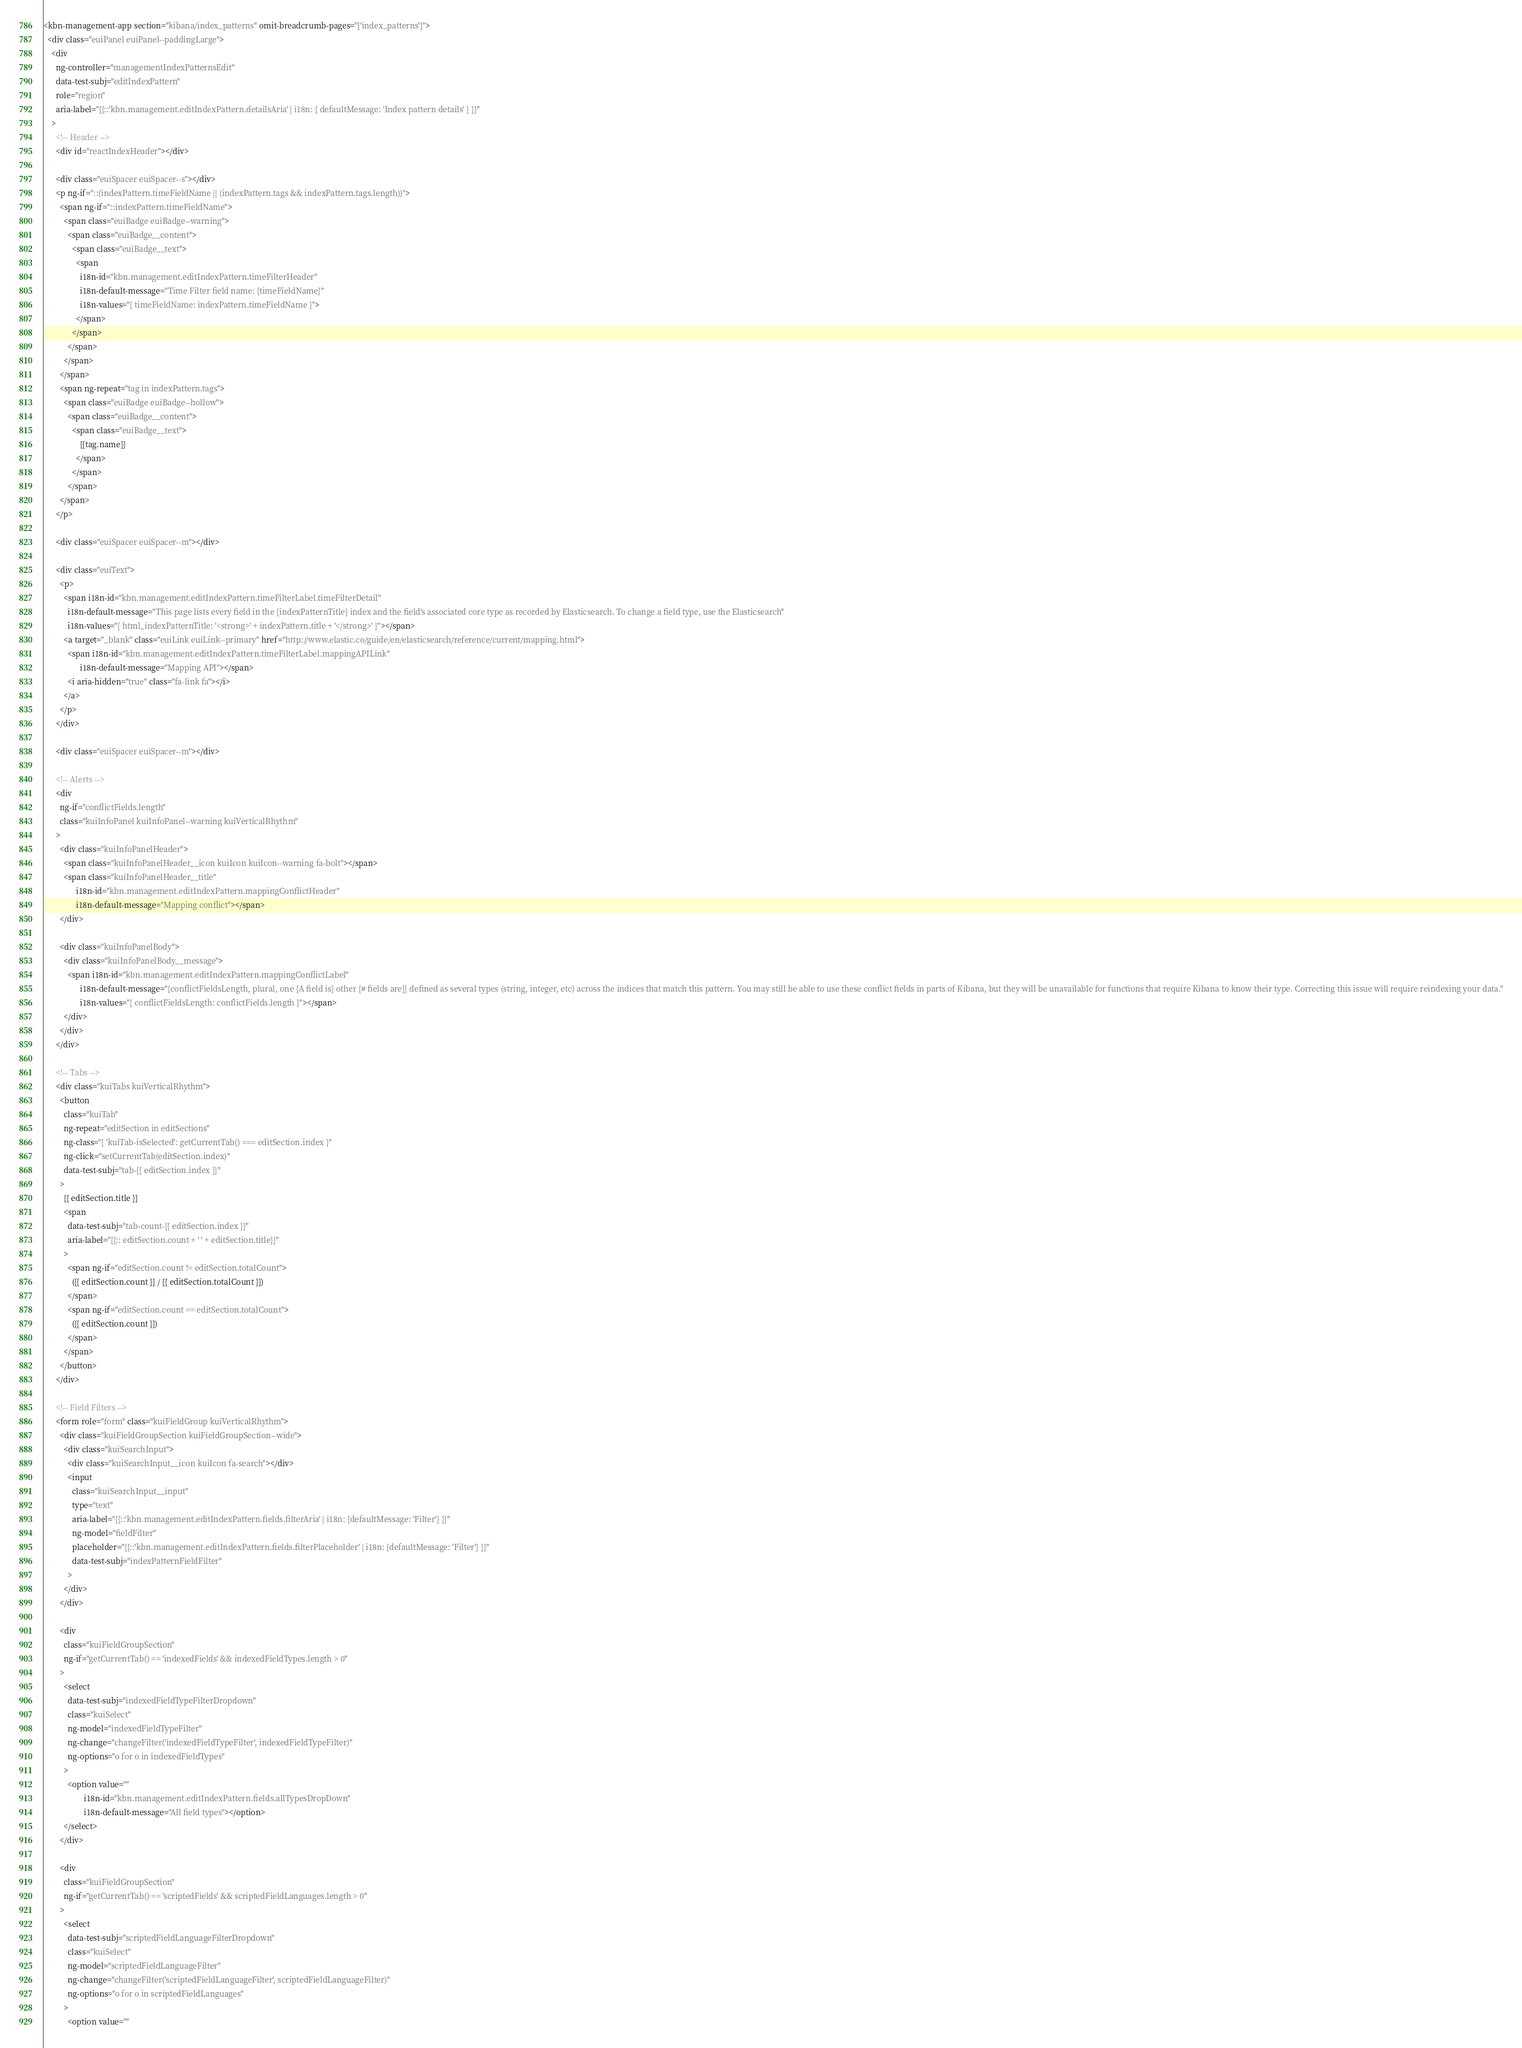Convert code to text. <code><loc_0><loc_0><loc_500><loc_500><_HTML_><kbn-management-app section="kibana/index_patterns" omit-breadcrumb-pages="['index_patterns']">
  <div class="euiPanel euiPanel--paddingLarge">
    <div
      ng-controller="managementIndexPatternsEdit"
      data-test-subj="editIndexPattern"
      role="region"
      aria-label="{{::'kbn.management.editIndexPattern.detailsAria' | i18n: { defaultMessage: 'Index pattern details' } }}"
    >
      <!-- Header -->
      <div id="reactIndexHeader"></div>

      <div class="euiSpacer euiSpacer--s"></div>
      <p ng-if="::(indexPattern.timeFieldName || (indexPattern.tags && indexPattern.tags.length))">
        <span ng-if="::indexPattern.timeFieldName">
          <span class="euiBadge euiBadge--warning">
            <span class="euiBadge__content">
              <span class="euiBadge__text">
                <span
                  i18n-id="kbn.management.editIndexPattern.timeFilterHeader"
                  i18n-default-message="Time Filter field name: {timeFieldName}"
                  i18n-values="{ timeFieldName: indexPattern.timeFieldName }">
                </span>
              </span>
            </span>
          </span>
        </span>
        <span ng-repeat="tag in indexPattern.tags">
          <span class="euiBadge euiBadge--hollow">
            <span class="euiBadge__content">
              <span class="euiBadge__text">
                  {{tag.name}}
                </span>
              </span>
            </span>
        </span>
      </p>

      <div class="euiSpacer euiSpacer--m"></div>

      <div class="euiText">
        <p>
          <span i18n-id="kbn.management.editIndexPattern.timeFilterLabel.timeFilterDetail"
            i18n-default-message="This page lists every field in the {indexPatternTitle} index and the field's associated core type as recorded by Elasticsearch. To change a field type, use the Elasticsearch"
            i18n-values="{ html_indexPatternTitle: '<strong>' + indexPattern.title + '</strong>' }"></span>
          <a target="_blank" class="euiLink euiLink--primary" href="http://www.elastic.co/guide/en/elasticsearch/reference/current/mapping.html">
            <span i18n-id="kbn.management.editIndexPattern.timeFilterLabel.mappingAPILink"
                  i18n-default-message="Mapping API"></span>
            <i aria-hidden="true" class="fa-link fa"></i>
          </a>
        </p>
      </div>

      <div class="euiSpacer euiSpacer--m"></div>

      <!-- Alerts -->
      <div
        ng-if="conflictFields.length"
        class="kuiInfoPanel kuiInfoPanel--warning kuiVerticalRhythm"
      >
        <div class="kuiInfoPanelHeader">
          <span class="kuiInfoPanelHeader__icon kuiIcon kuiIcon--warning fa-bolt"></span>
          <span class="kuiInfoPanelHeader__title"
                i18n-id="kbn.management.editIndexPattern.mappingConflictHeader"
                i18n-default-message="Mapping conflict"></span>
        </div>

        <div class="kuiInfoPanelBody">
          <div class="kuiInfoPanelBody__message">
            <span i18n-id="kbn.management.editIndexPattern.mappingConflictLabel"
                  i18n-default-message="{conflictFieldsLength, plural, one {A field is} other {# fields are}} defined as several types (string, integer, etc) across the indices that match this pattern. You may still be able to use these conflict fields in parts of Kibana, but they will be unavailable for functions that require Kibana to know their type. Correcting this issue will require reindexing your data."
                  i18n-values="{ conflictFieldsLength: conflictFields.length }"></span>
          </div>
        </div>
      </div>

      <!-- Tabs -->
      <div class="kuiTabs kuiVerticalRhythm">
        <button
          class="kuiTab"
          ng-repeat="editSection in editSections"
          ng-class="{ 'kuiTab-isSelected': getCurrentTab() === editSection.index }"
          ng-click="setCurrentTab(editSection.index)"
          data-test-subj="tab-{{ editSection.index }}"
        >
          {{ editSection.title }}
          <span
            data-test-subj="tab-count-{{ editSection.index }}"
            aria-label="{{:: editSection.count + ' ' + editSection.title}}"
          >
            <span ng-if="editSection.count != editSection.totalCount">
              ({{ editSection.count }} / {{ editSection.totalCount }})
            </span>
            <span ng-if="editSection.count == editSection.totalCount">
              ({{ editSection.count }})
            </span>
          </span>
        </button>
      </div>

      <!-- Field Filters -->
      <form role="form" class="kuiFieldGroup kuiVerticalRhythm">
        <div class="kuiFieldGroupSection kuiFieldGroupSection--wide">
          <div class="kuiSearchInput">
            <div class="kuiSearchInput__icon kuiIcon fa-search"></div>
            <input
              class="kuiSearchInput__input"
              type="text"
              aria-label="{{::'kbn.management.editIndexPattern.fields.filterAria' | i18n: {defaultMessage: 'Filter'} }}"
              ng-model="fieldFilter"
              placeholder="{{::'kbn.management.editIndexPattern.fields.filterPlaceholder' | i18n: {defaultMessage: 'Filter'} }}"
              data-test-subj="indexPatternFieldFilter"
            >
          </div>
        </div>

        <div
          class="kuiFieldGroupSection"
          ng-if="getCurrentTab() == 'indexedFields' && indexedFieldTypes.length > 0"
        >
          <select
            data-test-subj="indexedFieldTypeFilterDropdown"
            class="kuiSelect"
            ng-model="indexedFieldTypeFilter"
            ng-change="changeFilter('indexedFieldTypeFilter', indexedFieldTypeFilter)"
            ng-options="o for o in indexedFieldTypes"
          >
            <option value=""
                    i18n-id="kbn.management.editIndexPattern.fields.allTypesDropDown"
                    i18n-default-message="All field types"></option>
          </select>
        </div>

        <div
          class="kuiFieldGroupSection"
          ng-if="getCurrentTab() == 'scriptedFields' && scriptedFieldLanguages.length > 0"
        >
          <select
            data-test-subj="scriptedFieldLanguageFilterDropdown"
            class="kuiSelect"
            ng-model="scriptedFieldLanguageFilter"
            ng-change="changeFilter('scriptedFieldLanguageFilter', scriptedFieldLanguageFilter)"
            ng-options="o for o in scriptedFieldLanguages"
          >
            <option value=""</code> 